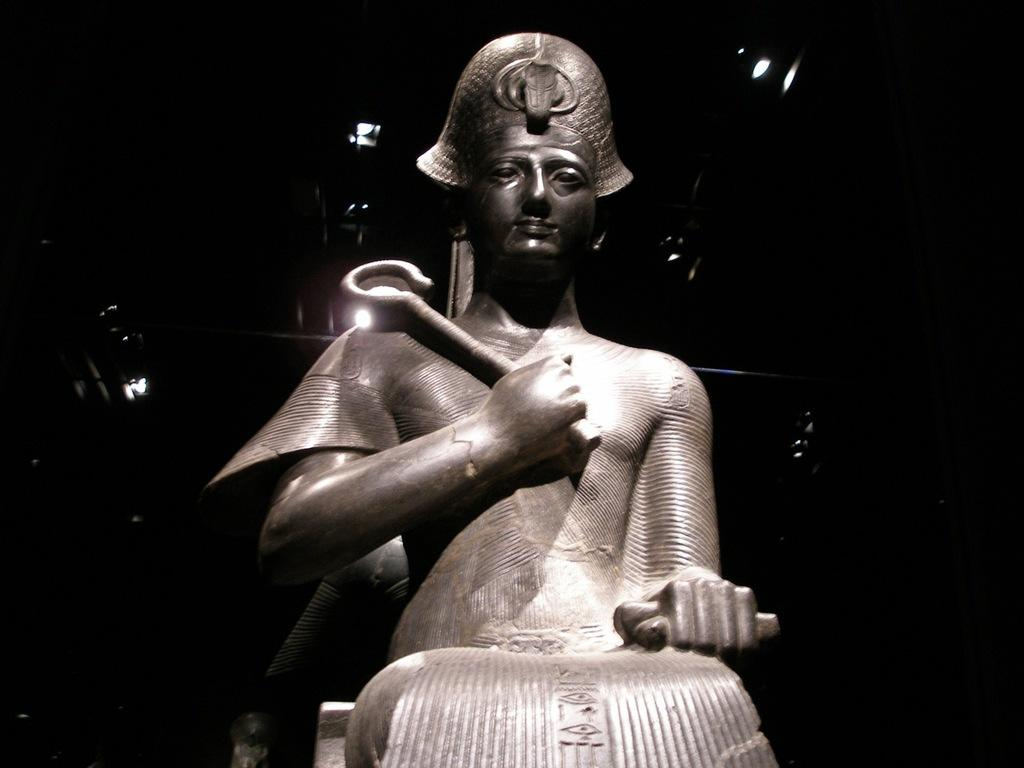What is the main subject in the center of the image? There is a statue in the center of the image. What can be seen illuminated in the image? There are lights visible in the image. How would you describe the overall lighting in the image? The background of the image appears dark. What type of magic is being performed by the dolls in the image? There are no dolls present in the image, so it is not possible to determine if any magic is being performed. 